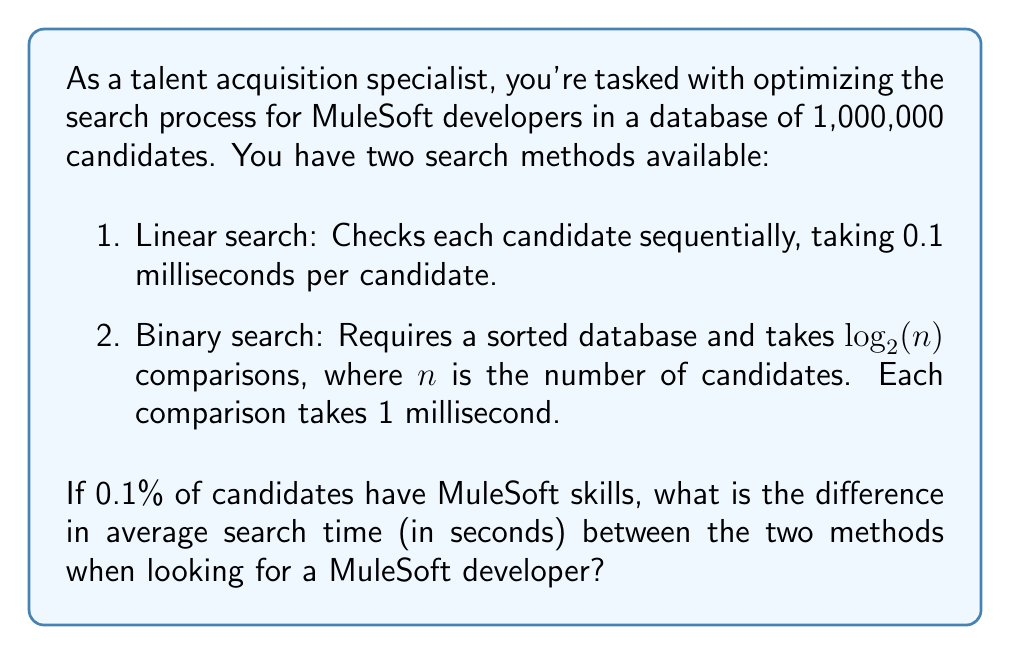Show me your answer to this math problem. Let's break this down step-by-step:

1. Linear Search:
   - Total candidates: $n = 1,000,000$
   - Time per candidate: $0.1$ ms
   - Average case: We need to search half of the database
   - Average time: $\frac{n}{2} \times 0.1$ ms
   - $\frac{1,000,000}{2} \times 0.1$ ms $= 50,000$ ms $= 50$ seconds

2. Binary Search:
   - Total candidates: $n = 1,000,000$
   - Number of comparisons: $\log_2(1,000,000) \approx 19.93$
   - Time per comparison: 1 ms
   - Average time: $19.93$ ms $\approx 0.02$ seconds

3. Probability calculation:
   - Probability of finding a MuleSoft developer: $0.1\% = 0.001$
   - Probability of not finding a MuleSoft developer: $99.9\% = 0.999$

4. Average search time:
   Linear search: $50 \times 0.001 + 50 \times 0.999 = 50$ seconds
   Binary search: $0.02 \times 0.001 + 50 \times 0.999 = 49.98$ seconds

5. Difference in average search time:
   $50 - 49.98 = 0.02$ seconds
Answer: The difference in average search time between linear search and binary search is 0.02 seconds. 